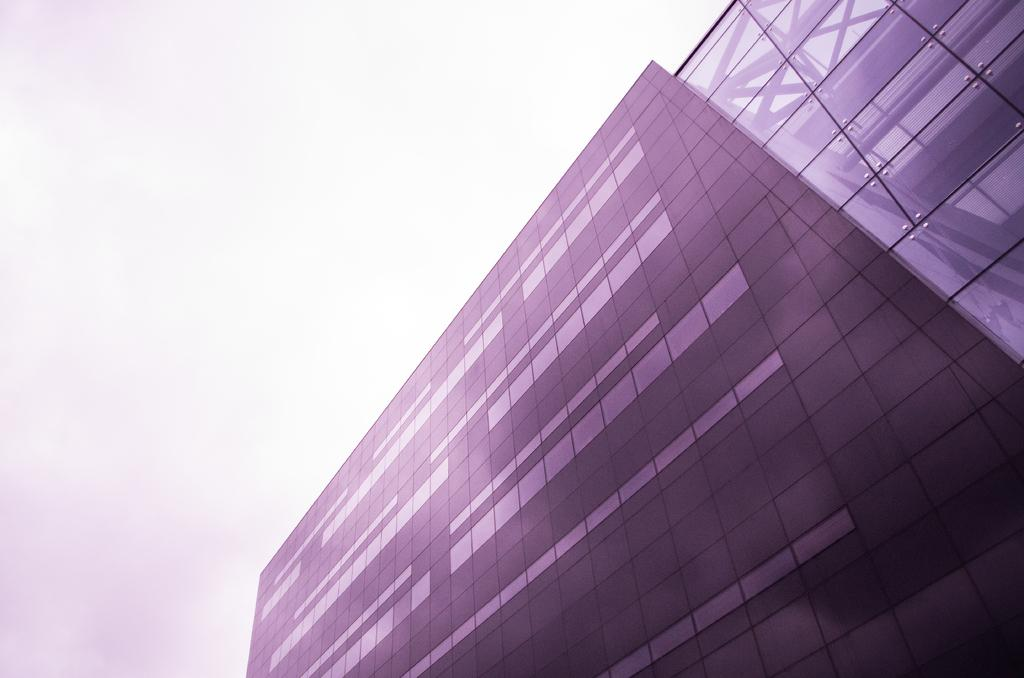What type of building is featured in the image? There is a glass building in the image. What can be observed about the sky in the image? The sky is white in color. Where is the goat located in the image? There is no goat present in the image. What is the best way to reach the top of the glass building in the image? The facts provided do not give information about how to reach the top of the building, nor is there any indication of a goat or a way to reach the top. 